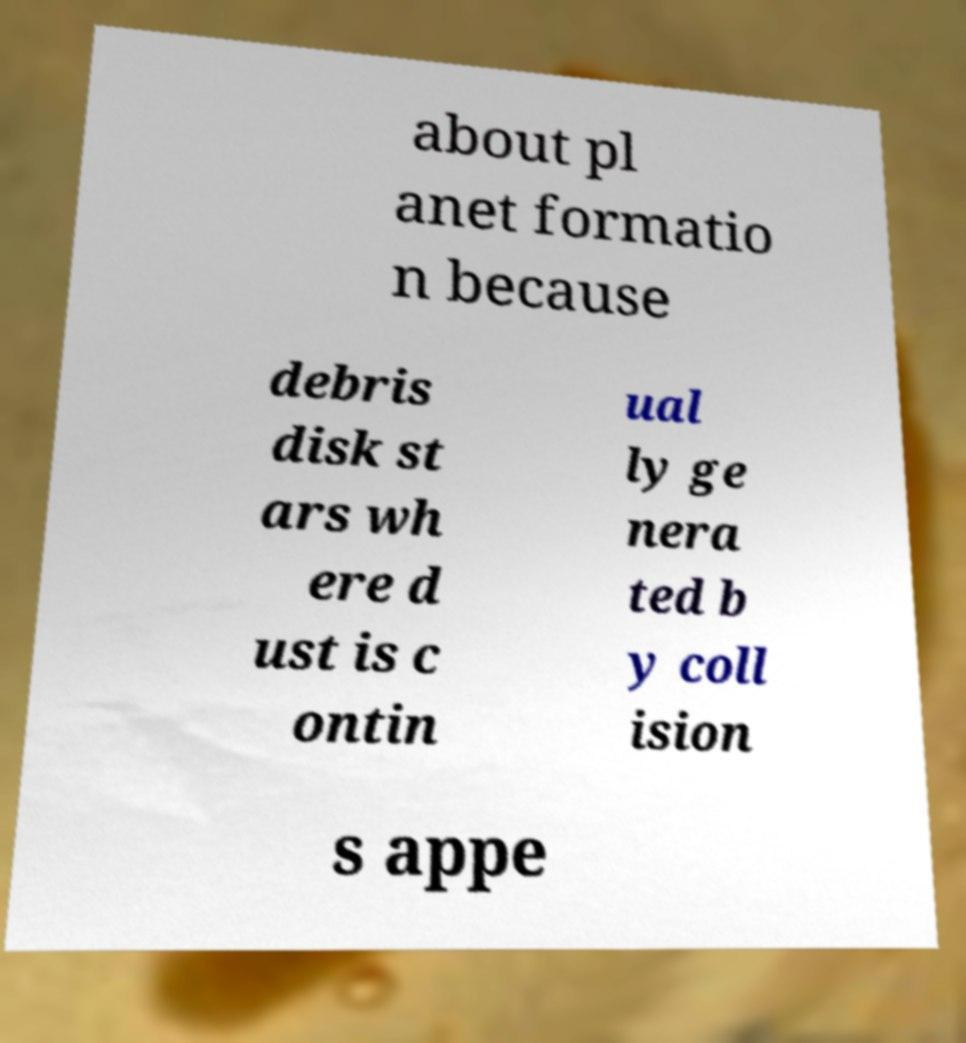Can you read and provide the text displayed in the image?This photo seems to have some interesting text. Can you extract and type it out for me? about pl anet formatio n because debris disk st ars wh ere d ust is c ontin ual ly ge nera ted b y coll ision s appe 